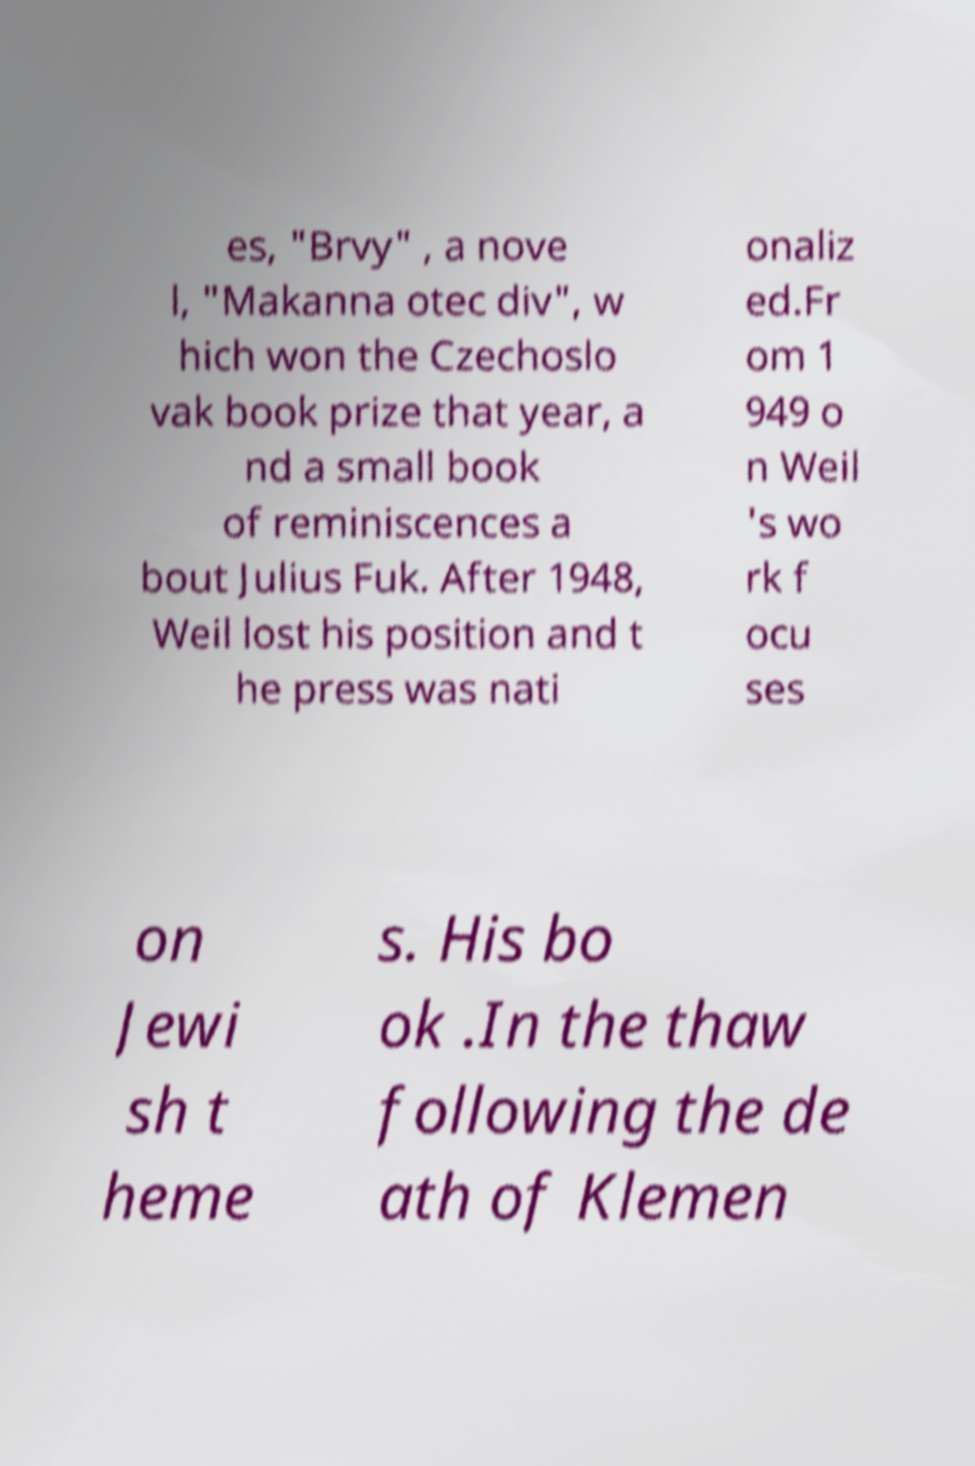Can you read and provide the text displayed in the image?This photo seems to have some interesting text. Can you extract and type it out for me? es, "Brvy" , a nove l, "Makanna otec div", w hich won the Czechoslo vak book prize that year, a nd a small book of reminiscences a bout Julius Fuk. After 1948, Weil lost his position and t he press was nati onaliz ed.Fr om 1 949 o n Weil 's wo rk f ocu ses on Jewi sh t heme s. His bo ok .In the thaw following the de ath of Klemen 